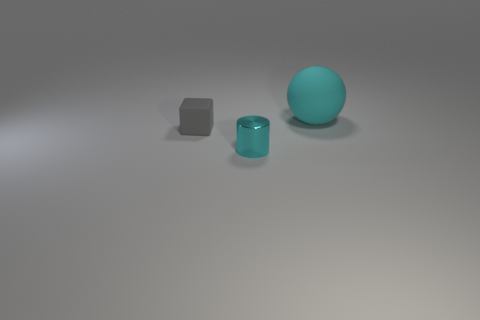Is the material of the small cylinder the same as the big cyan object?
Your response must be concise. No. There is a cyan cylinder that is the same size as the gray rubber thing; what is it made of?
Give a very brief answer. Metal. How many objects are either small things behind the shiny object or cyan shiny things?
Make the answer very short. 2. Are there the same number of large cyan matte things in front of the cyan metal thing and objects?
Provide a succinct answer. No. Is the color of the tiny rubber block the same as the big ball?
Keep it short and to the point. No. The object that is both right of the gray cube and to the left of the ball is what color?
Your response must be concise. Cyan. How many blocks are small brown rubber things or small metallic things?
Give a very brief answer. 0. Is the number of tiny matte blocks that are behind the gray matte thing less than the number of tiny rubber cylinders?
Keep it short and to the point. No. There is another object that is the same material as the large cyan object; what is its shape?
Your response must be concise. Cube. How many shiny objects are the same color as the large rubber object?
Make the answer very short. 1. 